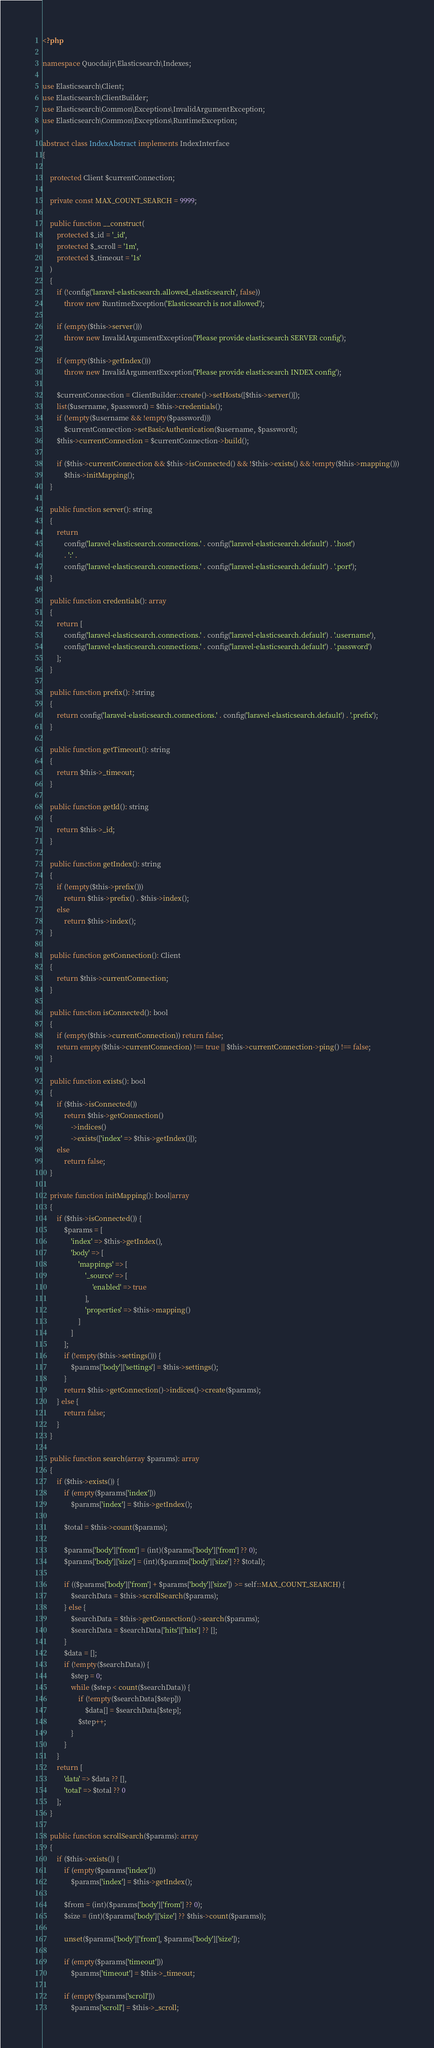Convert code to text. <code><loc_0><loc_0><loc_500><loc_500><_PHP_><?php

namespace Quocdaijr\Elasticsearch\Indexes;

use Elasticsearch\Client;
use Elasticsearch\ClientBuilder;
use Elasticsearch\Common\Exceptions\InvalidArgumentException;
use Elasticsearch\Common\Exceptions\RuntimeException;

abstract class IndexAbstract implements IndexInterface
{

    protected Client $currentConnection;

    private const MAX_COUNT_SEARCH = 9999;

    public function __construct(
        protected $_id = '_id',
        protected $_scroll = '1m',
        protected $_timeout = '1s'
    )
    {
        if (!config('laravel-elasticsearch.allowed_elasticsearch', false))
            throw new RuntimeException('Elasticsearch is not allowed');

        if (empty($this->server()))
            throw new InvalidArgumentException('Please provide elasticsearch SERVER config');

        if (empty($this->getIndex()))
            throw new InvalidArgumentException('Please provide elasticsearch INDEX config');

        $currentConnection = ClientBuilder::create()->setHosts([$this->server()]);
        list($username, $password) = $this->credentials();
        if (!empty($username && !empty($password)))
            $currentConnection->setBasicAuthentication($username, $password);
        $this->currentConnection = $currentConnection->build();

        if ($this->currentConnection && $this->isConnected() && !$this->exists() && !empty($this->mapping()))
            $this->initMapping();
    }

    public function server(): string
    {
        return
            config('laravel-elasticsearch.connections.' . config('laravel-elasticsearch.default') . '.host')
            . ':' .
            config('laravel-elasticsearch.connections.' . config('laravel-elasticsearch.default') . '.port');
    }

    public function credentials(): array
    {
        return [
            config('laravel-elasticsearch.connections.' . config('laravel-elasticsearch.default') . '.username'),
            config('laravel-elasticsearch.connections.' . config('laravel-elasticsearch.default') . '.password')
        ];
    }

    public function prefix(): ?string
    {
        return config('laravel-elasticsearch.connections.' . config('laravel-elasticsearch.default') . '.prefix');
    }

    public function getTimeout(): string
    {
        return $this->_timeout;
    }

    public function getId(): string
    {
        return $this->_id;
    }

    public function getIndex(): string
    {
        if (!empty($this->prefix()))
            return $this->prefix() . $this->index();
        else
            return $this->index();
    }

    public function getConnection(): Client
    {
        return $this->currentConnection;
    }

    public function isConnected(): bool
    {
        if (empty($this->currentConnection)) return false;
        return empty($this->currentConnection) !== true || $this->currentConnection->ping() !== false;
    }

    public function exists(): bool
    {
        if ($this->isConnected())
            return $this->getConnection()
                ->indices()
                ->exists(['index' => $this->getIndex()]);
        else
            return false;
    }

    private function initMapping(): bool|array
    {
        if ($this->isConnected()) {
            $params = [
                'index' => $this->getIndex(),
                'body' => [
                    'mappings' => [
                        '_source' => [
                            'enabled' => true
                        ],
                        'properties' => $this->mapping()
                    ]
                ]
            ];
            if (!empty($this->settings())) {
                $params['body']['settings'] = $this->settings();
            }
            return $this->getConnection()->indices()->create($params);
        } else {
            return false;
        }
    }

    public function search(array $params): array
    {
        if ($this->exists()) {
            if (empty($params['index']))
                $params['index'] = $this->getIndex();

            $total = $this->count($params);

            $params['body']['from'] = (int)($params['body']['from'] ?? 0);
            $params['body']['size'] = (int)($params['body']['size'] ?? $total);

            if (($params['body']['from'] + $params['body']['size']) >= self::MAX_COUNT_SEARCH) {
                $searchData = $this->scrollSearch($params);
            } else {
                $searchData = $this->getConnection()->search($params);
                $searchData = $searchData['hits']['hits'] ?? [];
            }
            $data = [];
            if (!empty($searchData)) {
                $step = 0;
                while ($step < count($searchData)) {
                    if (!empty($searchData[$step]))
                        $data[] = $searchData[$step];
                    $step++;
                }
            }
        }
        return [
            'data' => $data ?? [],
            'total' => $total ?? 0
        ];
    }

    public function scrollSearch($params): array
    {
        if ($this->exists()) {
            if (empty($params['index']))
                $params['index'] = $this->getIndex();

            $from = (int)($params['body']['from'] ?? 0);
            $size = (int)($params['body']['size'] ?? $this->count($params));

            unset($params['body']['from'], $params['body']['size']);

            if (empty($params['timeout']))
                $params['timeout'] = $this->_timeout;

            if (empty($params['scroll']))
                $params['scroll'] = $this->_scroll;
</code> 